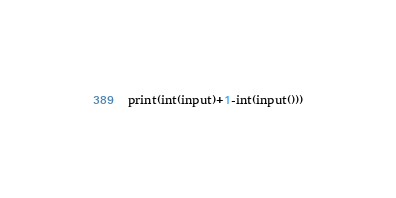<code> <loc_0><loc_0><loc_500><loc_500><_Python_>print(int(input)+1-int(input()))</code> 